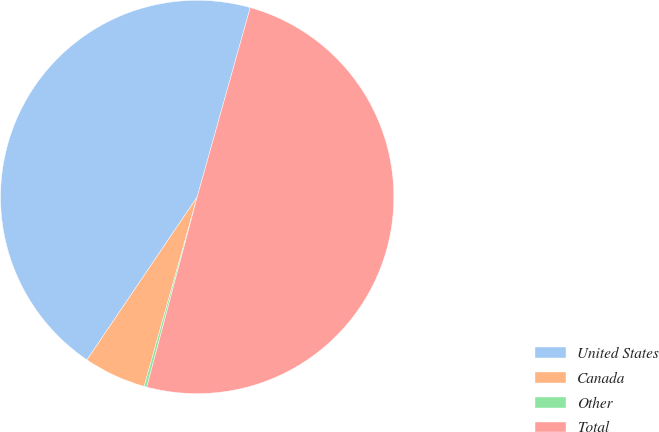<chart> <loc_0><loc_0><loc_500><loc_500><pie_chart><fcel>United States<fcel>Canada<fcel>Other<fcel>Total<nl><fcel>44.88%<fcel>5.12%<fcel>0.22%<fcel>49.78%<nl></chart> 